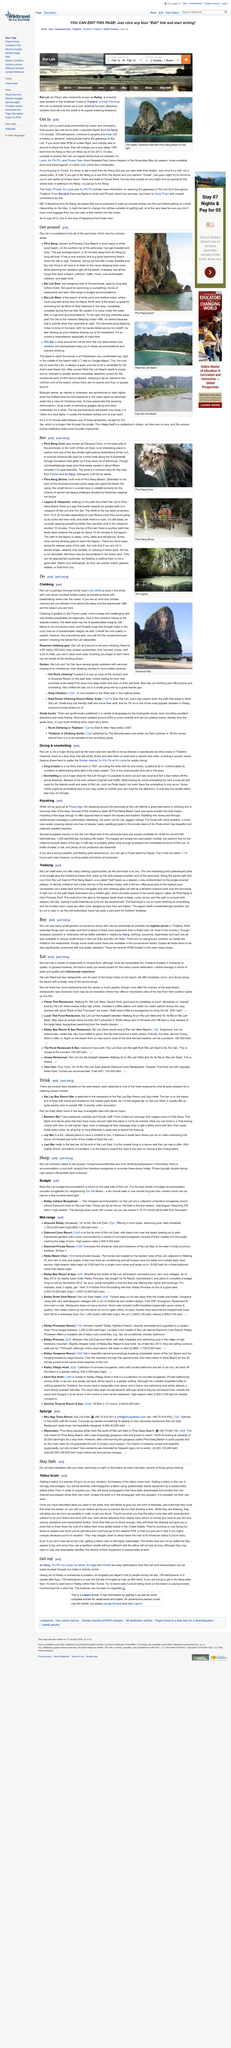Draw attention to some important aspects in this diagram. A long tail boat trip from Ao Nang to Phra Nang typically takes approximately 20 minutes. According to the article "Get around", the peninsula has 4 primary areas. Phra Nang Beach, also known as Pranang Cave Beach, is renowned for its stunning beauty and is a popular tourist destination. 